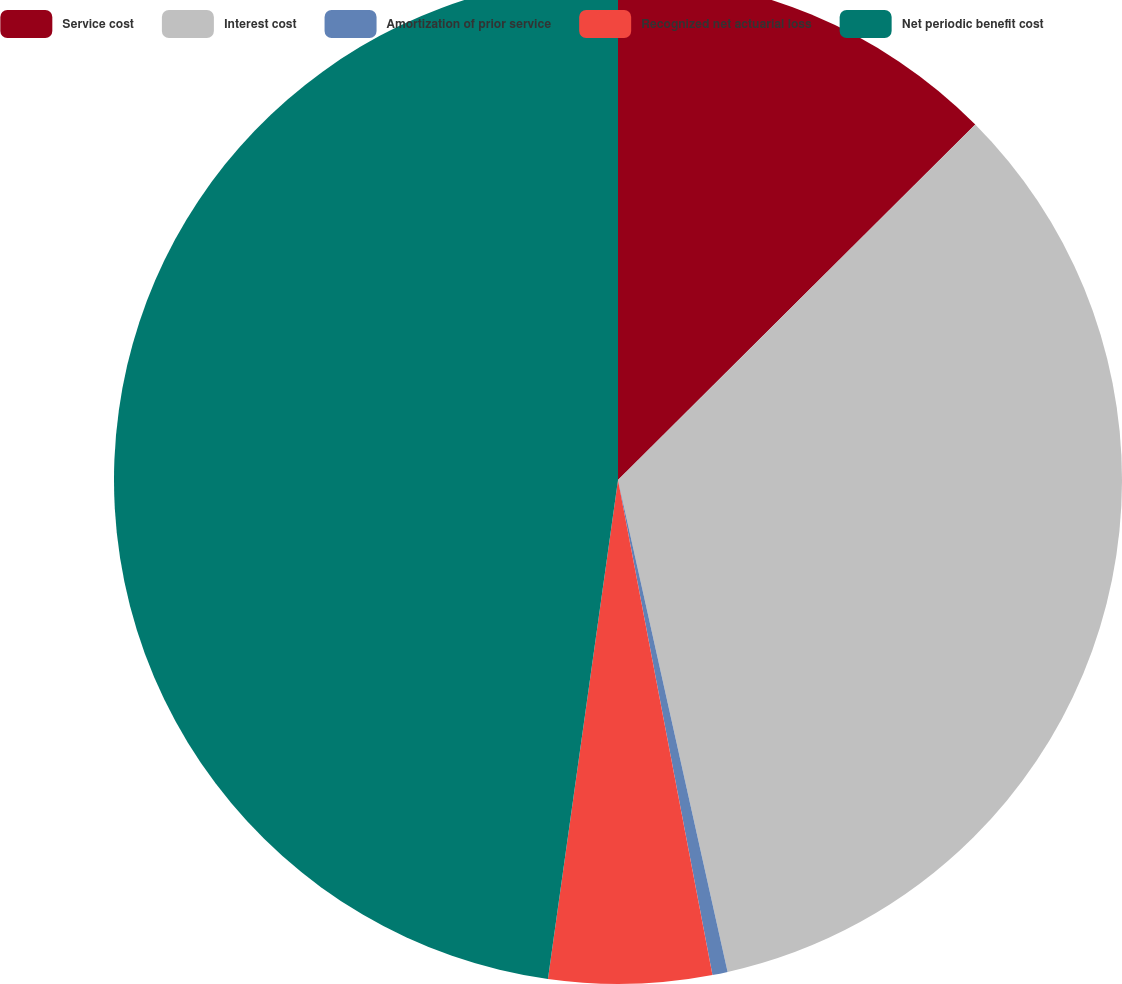Convert chart to OTSL. <chart><loc_0><loc_0><loc_500><loc_500><pie_chart><fcel>Service cost<fcel>Interest cost<fcel>Amortization of prior service<fcel>Recognized net actuarial loss<fcel>Net periodic benefit cost<nl><fcel>12.54%<fcel>33.97%<fcel>0.49%<fcel>5.22%<fcel>47.78%<nl></chart> 